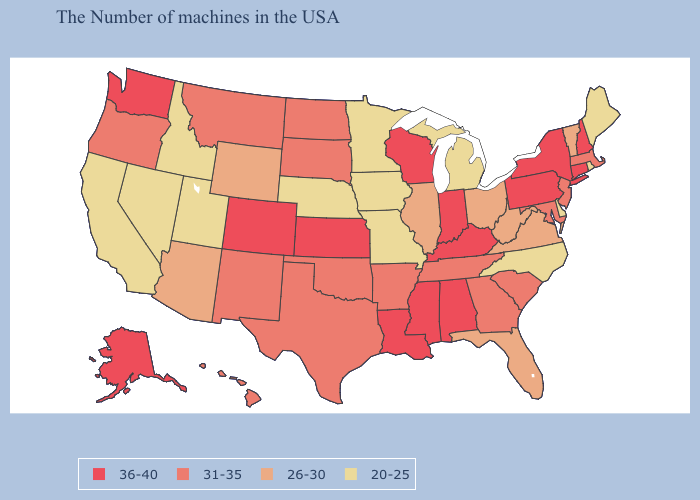Name the states that have a value in the range 26-30?
Write a very short answer. Vermont, Virginia, West Virginia, Ohio, Florida, Illinois, Wyoming, Arizona. Does Washington have a higher value than Colorado?
Keep it brief. No. What is the value of California?
Keep it brief. 20-25. Does the map have missing data?
Quick response, please. No. What is the highest value in the USA?
Concise answer only. 36-40. Which states have the highest value in the USA?
Answer briefly. New Hampshire, Connecticut, New York, Pennsylvania, Kentucky, Indiana, Alabama, Wisconsin, Mississippi, Louisiana, Kansas, Colorado, Washington, Alaska. Among the states that border Illinois , does Wisconsin have the highest value?
Answer briefly. Yes. What is the value of New Jersey?
Short answer required. 31-35. Does New Hampshire have a higher value than Nevada?
Short answer required. Yes. Does Alaska have the highest value in the USA?
Keep it brief. Yes. What is the value of Alabama?
Keep it brief. 36-40. Does New Jersey have the same value as New Mexico?
Give a very brief answer. Yes. Does Missouri have the lowest value in the USA?
Short answer required. Yes. Name the states that have a value in the range 20-25?
Answer briefly. Maine, Rhode Island, Delaware, North Carolina, Michigan, Missouri, Minnesota, Iowa, Nebraska, Utah, Idaho, Nevada, California. Which states hav the highest value in the West?
Quick response, please. Colorado, Washington, Alaska. 